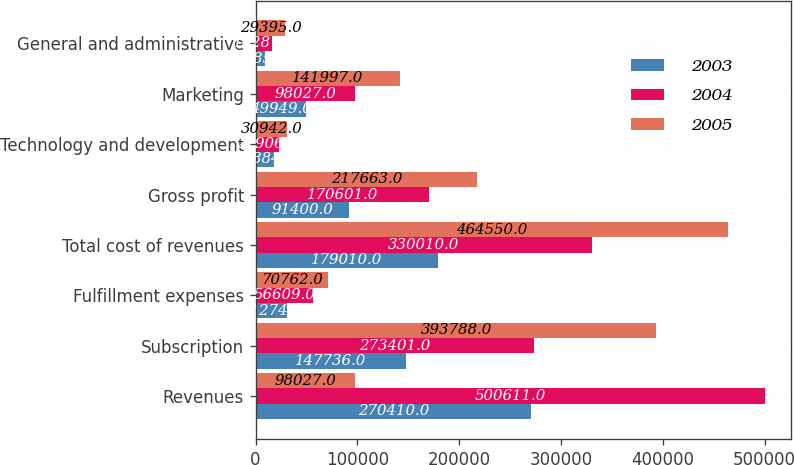Convert chart. <chart><loc_0><loc_0><loc_500><loc_500><stacked_bar_chart><ecel><fcel>Revenues<fcel>Subscription<fcel>Fulfillment expenses<fcel>Total cost of revenues<fcel>Gross profit<fcel>Technology and development<fcel>Marketing<fcel>General and administrative<nl><fcel>2003<fcel>270410<fcel>147736<fcel>31274<fcel>179010<fcel>91400<fcel>17884<fcel>49949<fcel>9585<nl><fcel>2004<fcel>500611<fcel>273401<fcel>56609<fcel>330010<fcel>170601<fcel>22906<fcel>98027<fcel>16287<nl><fcel>2005<fcel>98027<fcel>393788<fcel>70762<fcel>464550<fcel>217663<fcel>30942<fcel>141997<fcel>29395<nl></chart> 